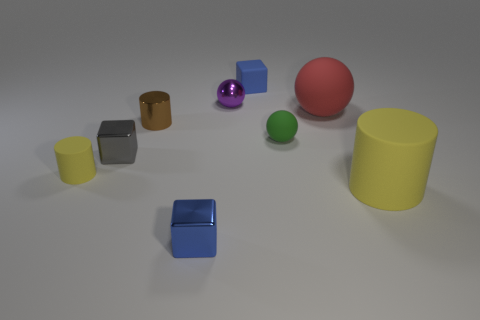Add 1 cyan metallic cylinders. How many objects exist? 10 Subtract all balls. How many objects are left? 6 Subtract 2 blue cubes. How many objects are left? 7 Subtract all gray shiny objects. Subtract all tiny purple spheres. How many objects are left? 7 Add 8 yellow cylinders. How many yellow cylinders are left? 10 Add 6 brown metal blocks. How many brown metal blocks exist? 6 